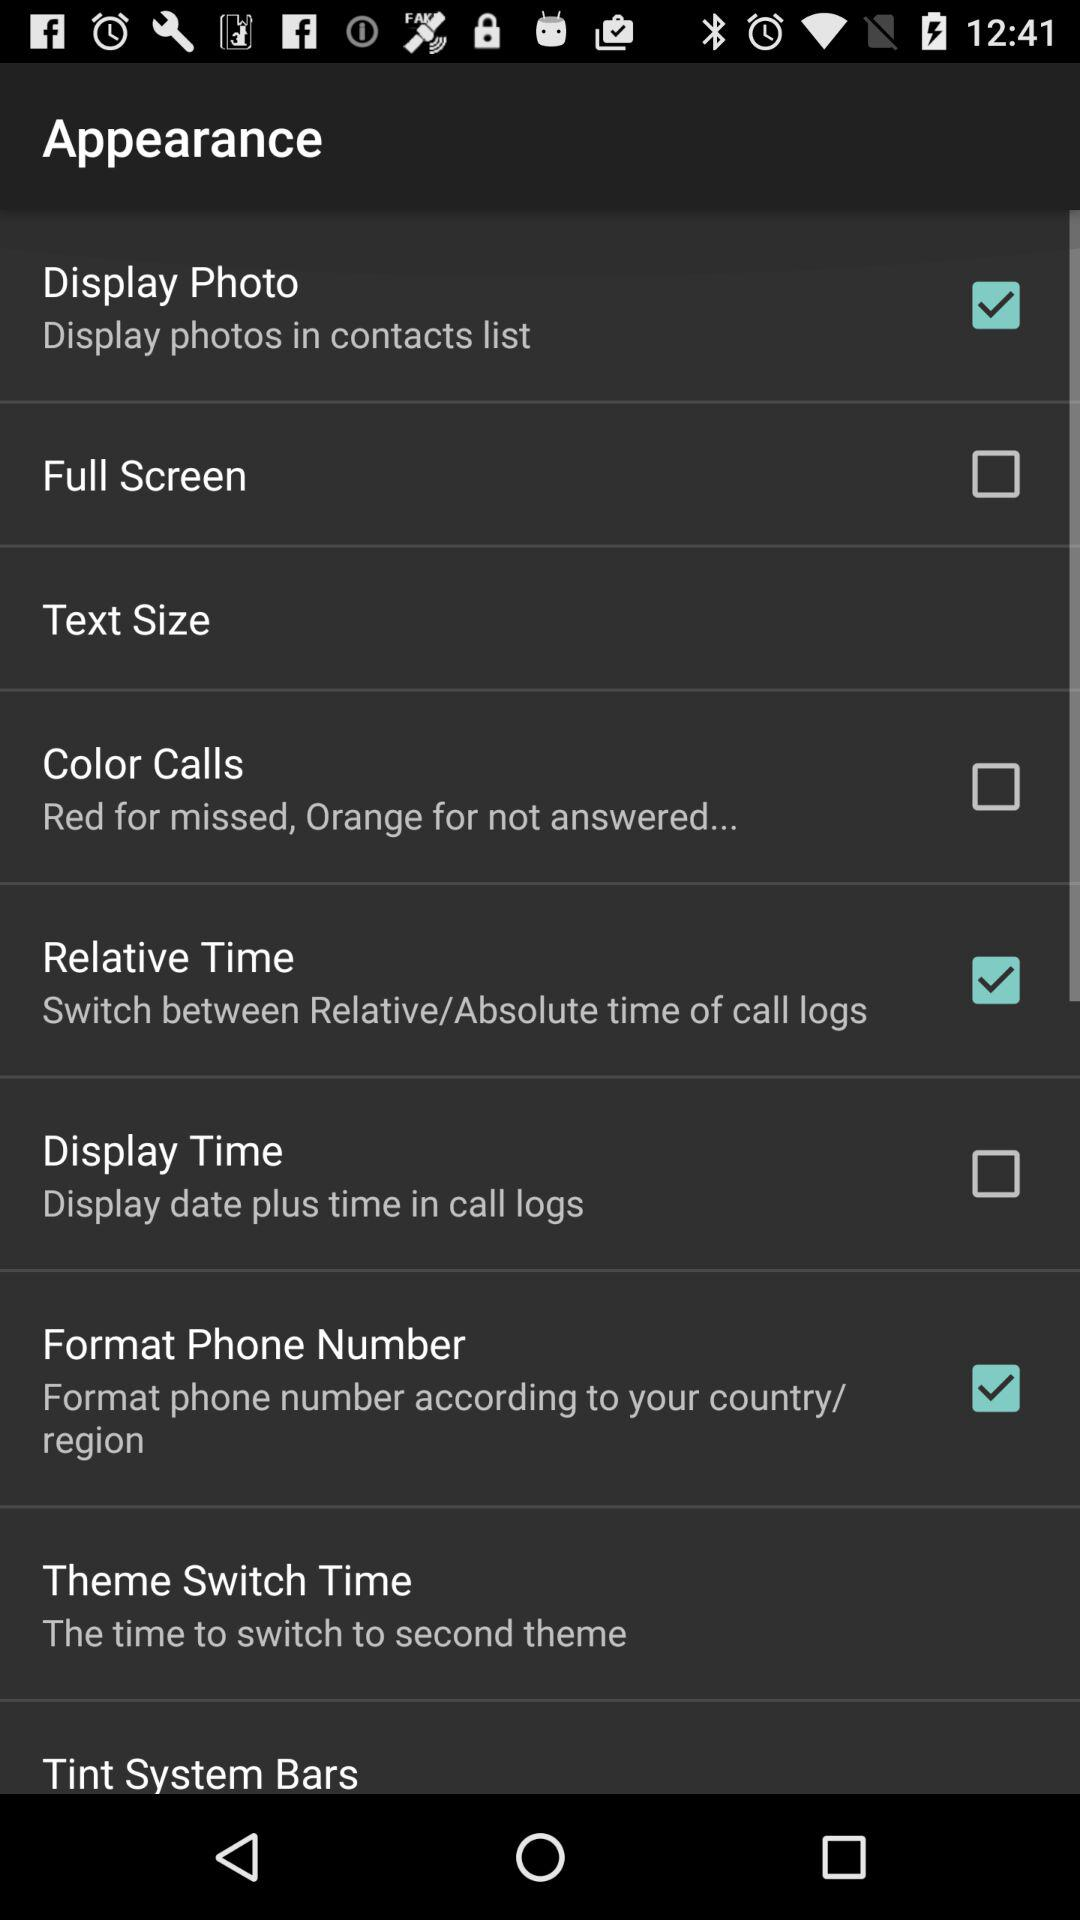What is the description of "Relative Time"? The description of "Relative Time" is "Switch between Relative/Absolute time of call logs". 